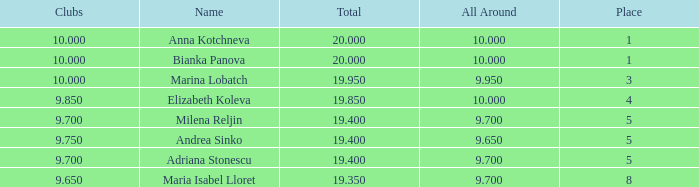What total has 10 as the clubs, with a place greater than 1? 19.95. 